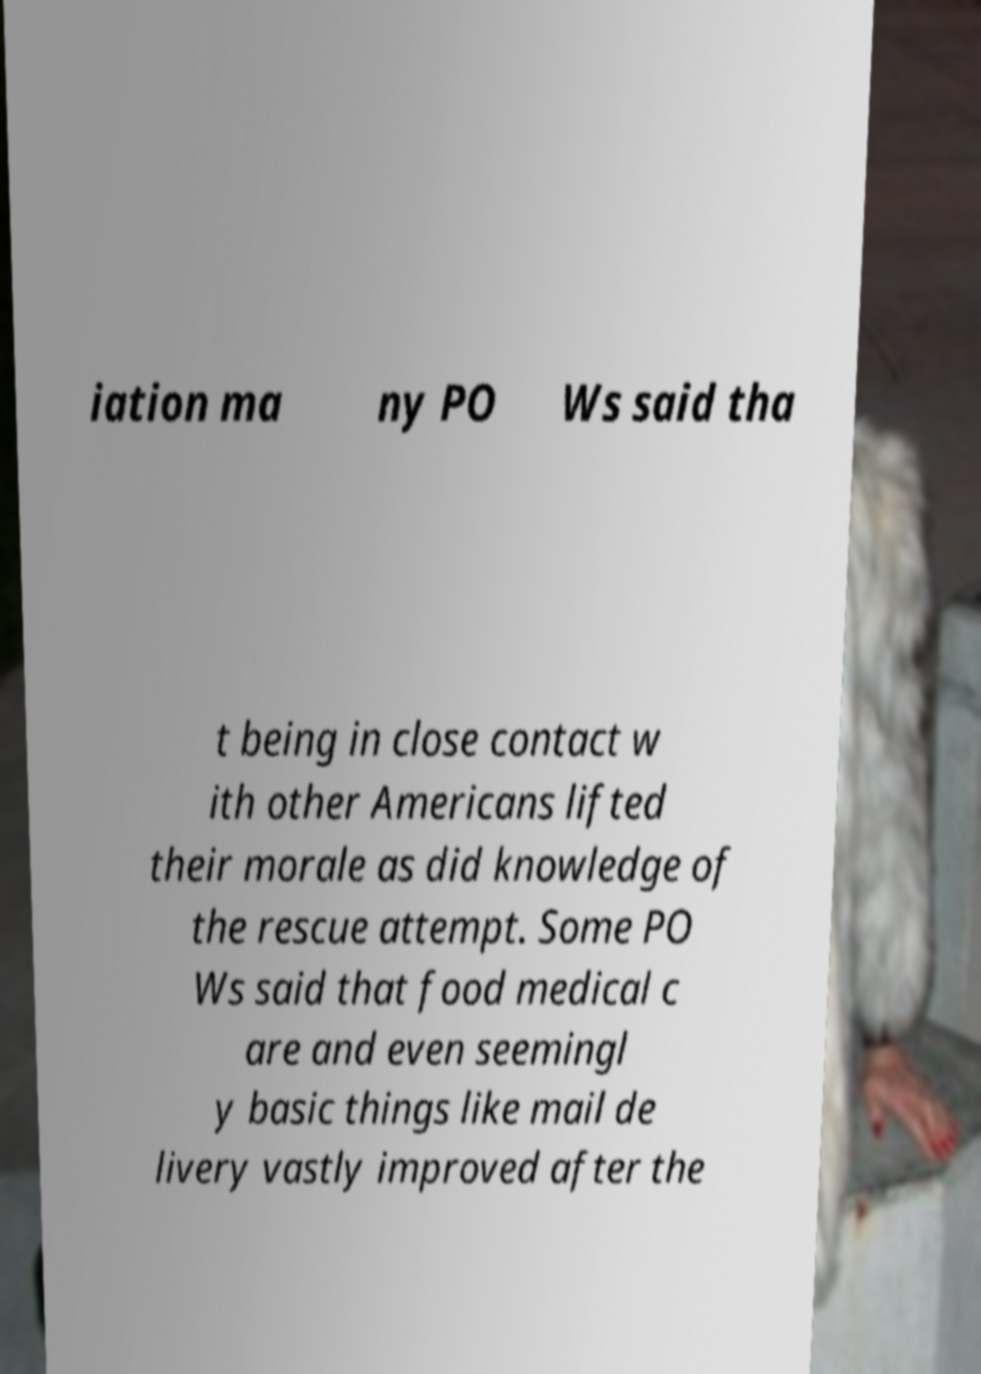Could you assist in decoding the text presented in this image and type it out clearly? iation ma ny PO Ws said tha t being in close contact w ith other Americans lifted their morale as did knowledge of the rescue attempt. Some PO Ws said that food medical c are and even seemingl y basic things like mail de livery vastly improved after the 